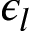<formula> <loc_0><loc_0><loc_500><loc_500>\epsilon _ { l }</formula> 